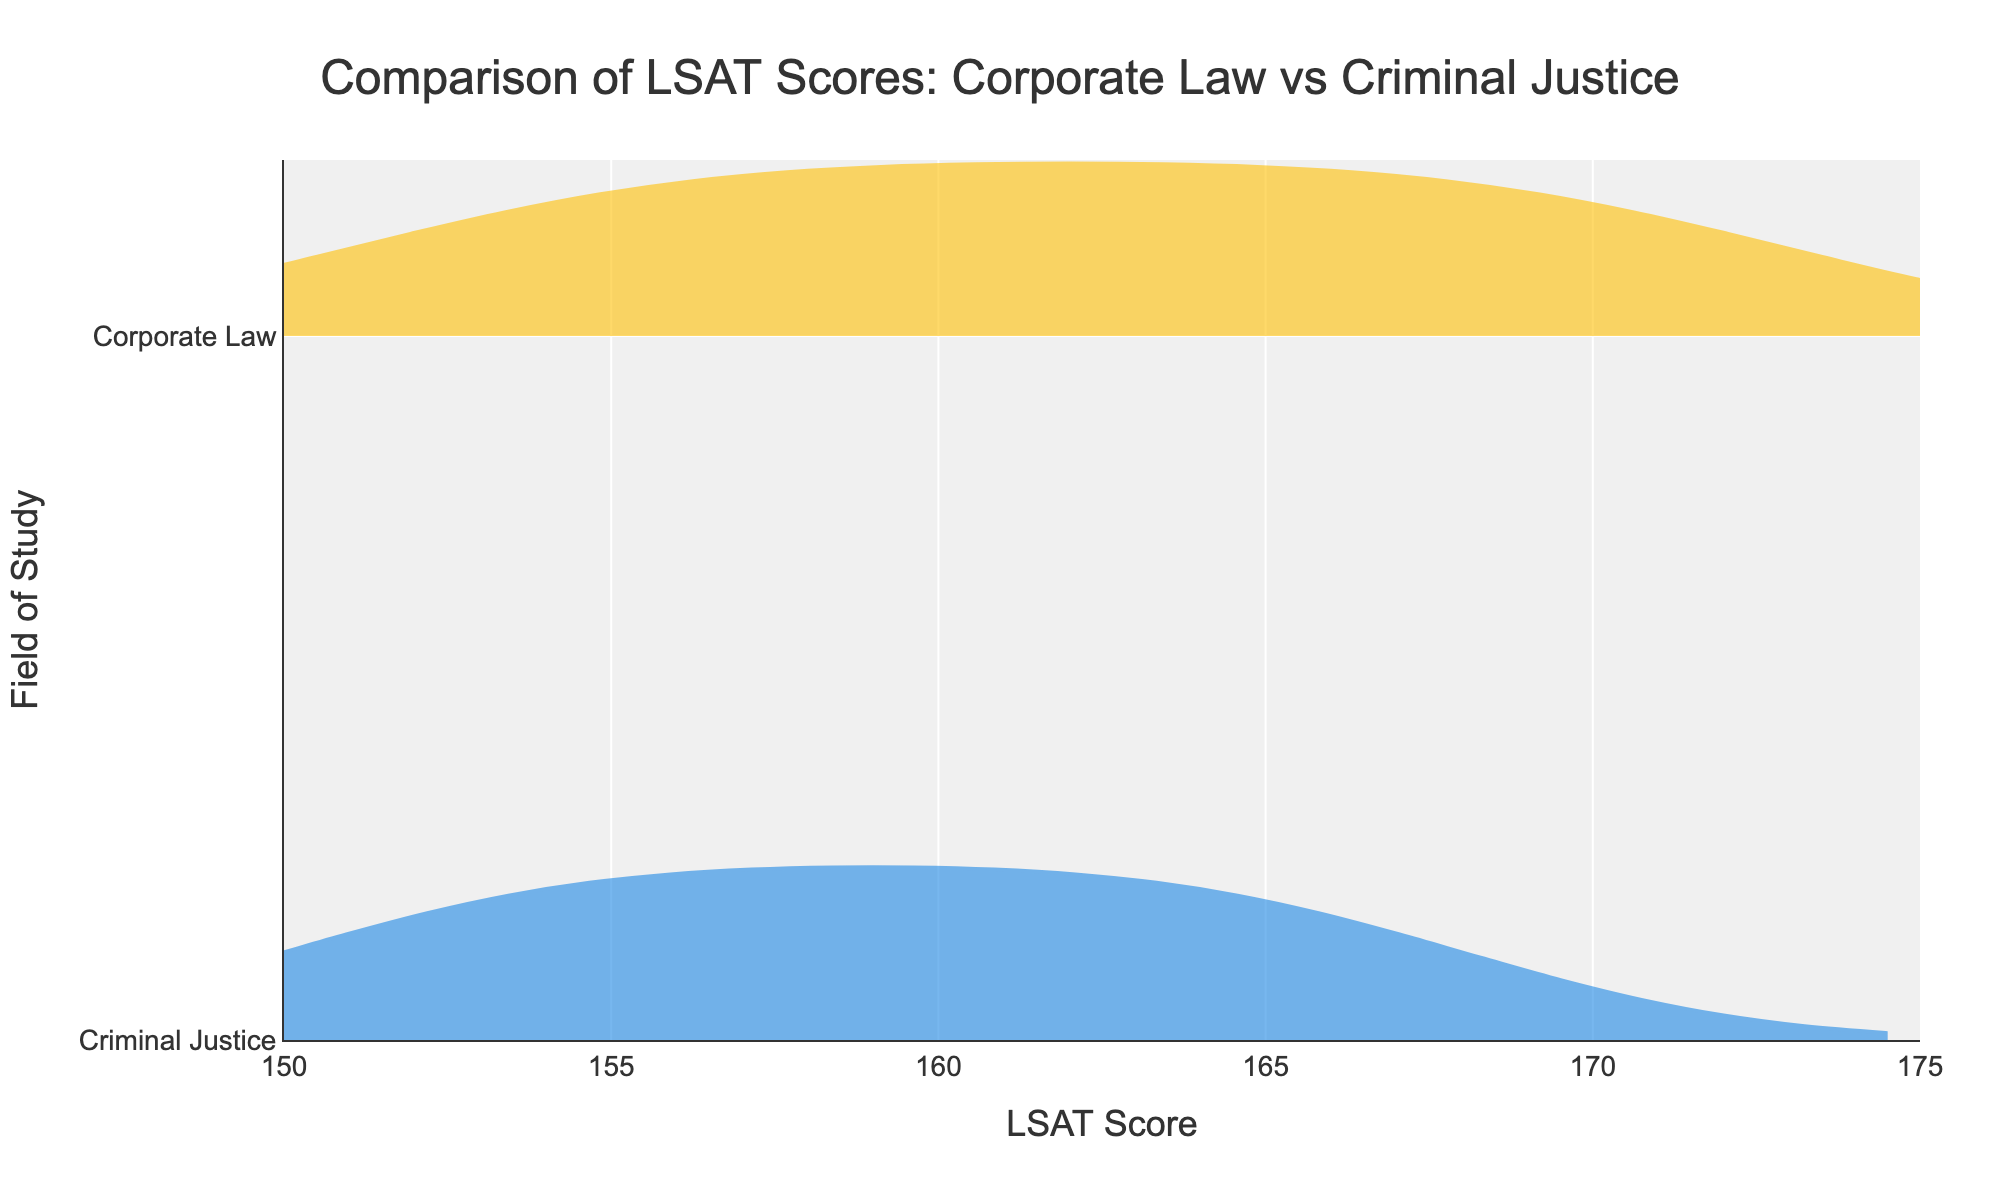What is the title of the figure? The title of the figure is usually displayed at the top, italicized or bolded, providing a brief description of the visualized data. Here, the title appears to be centered at the top of the figure.
Answer: Comparison of LSAT Scores: Corporate Law vs Criminal Justice What is the x-axis representing in the plot? The x-axis title is shown at the bottom of the plot and usually describes what is being measured along the horizontal axis. In this case, it shows "LSAT Score."
Answer: LSAT Score How many fields of study are compared in the plot? By looking at the distinct violin shapes and the y-axis labels, we can identify the number of unique fields of study being compared in the figure. There are two labels corresponding to this comparison.
Answer: 2 What color is used to represent the LSAT scores for Corporate Law students? The violin plot uses specific colors to differentiate between the two groups. The color associated with Corporate Law can be easily identified by referring to the figure legend or the fill color of the corresponding trace.
Answer: Yellow Which field of study has a higher peak frequency LSAT score? Observing the height and width of the peaks in the violin plots will show which field has a higher frequency at its peak LSAT score. The group with the broader section in their violin plot represents a higher frequency.
Answer: Corporate Law What is the range of LSAT scores for Criminal Justice students? The range of LSAT scores is determined by identifying the minimum and maximum horizontal extent of the Criminal Justice violin plot.
Answer: 151-167 What is the lowest LSAT score recorded for Corporate Law students? By looking at the leftmost edge of the Corporate Law violin plot, we can find the lowest LSAT score recorded for this group.
Answer: 152 Which field of study shows more variation in LSAT scores? More variation can be detected by comparing the widths and spreads of the two violin plots. The group with a wider spread or i.e., a more extended violin plot, indicates greater variation.
Answer: Corporate Law What is the highest LSAT score recorded for Corporate Law students? The highest recorded score can be seen by looking at the rightmost edge of the violin plot for Corporate Law.
Answer: 172 Which field of study has a higher concentration of LSAT scores in the middle range (155-165)? To determine which field has more scores in the middle range, examine which violin plot is broader between LSAT scores 155 and 165. Broader sections indicate higher concentrations.
Answer: Criminal Justice How does the distribution of LSAT scores for Criminal Justice students compare to that of Corporate Law students? By assessing the shape, spread, and peak locations of both violin plots, you can compare the distributions, noting elements like concentration, dispersion, and where most scores fall.
Answer: Criminal Justice is more concentrated around the middle LSAT scores (155-165), while Corporate Law has a wider spread with peaks at both middle and higher scores 